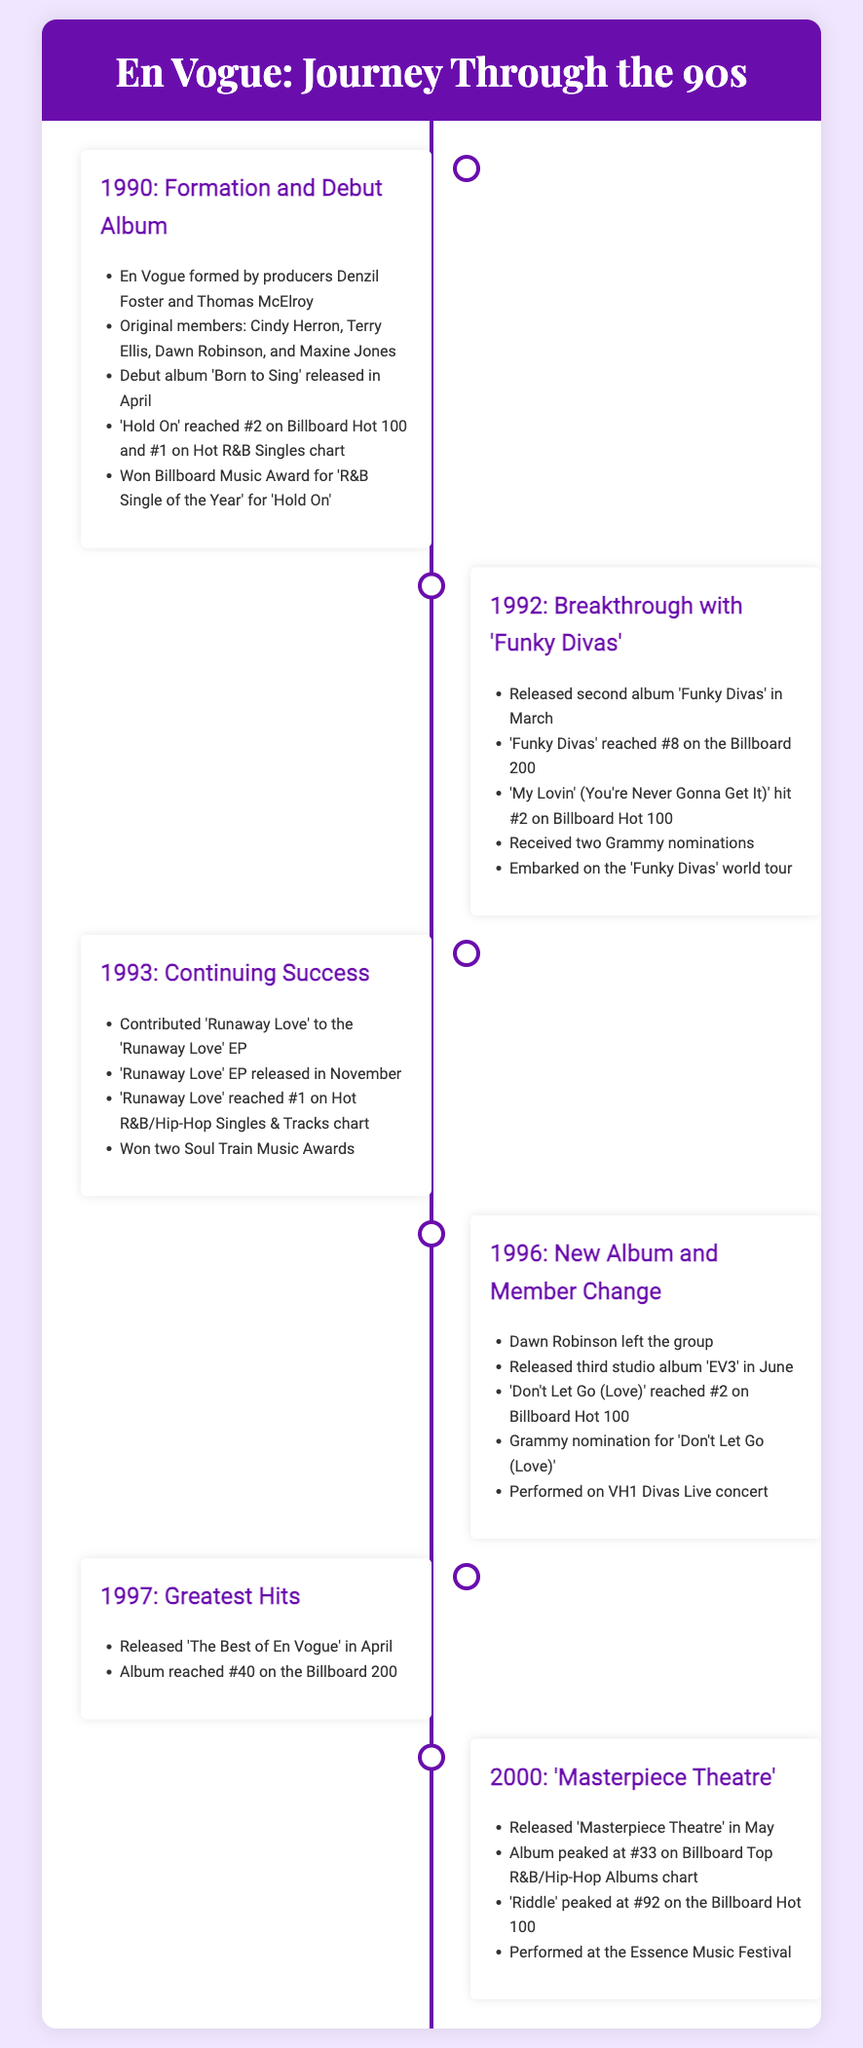What year was En Vogue formed? The document states that En Vogue was formed in 1990.
Answer: 1990 What was the title of En Vogue's debut album? The fact sheet mentions that their debut album is 'Born to Sing'.
Answer: Born to Sing Which single reached #1 on the Hot R&B Singles chart in 1990? According to the document, 'Hold On' reached #1 on the Hot R&B Singles chart.
Answer: Hold On How many Grammy nominations did En Vogue receive in 1992? The document states that they received two Grammy nominations in 1992.
Answer: Two What was the peak position of 'My Lovin' (You're Never Gonna Get It)' on the Billboard Hot 100? The timeline indicates that it hit #2 on the Billboard Hot 100.
Answer: #2 What significant event occurred in 1996? According to the document, Dawn Robinson left the group in 1996.
Answer: Dawn Robinson left What was the title of En Vogue's album released in 2000? The fact sheet notes that the album released in 2000 is 'Masterpiece Theatre'.
Answer: Masterpiece Theatre How many singles were mentioned from the album 'EV3'? The document refers to one single, 'Don't Let Go (Love)'.
Answer: One Which festival did En Vogue perform at in 2000? According to the fact sheet, they performed at the Essence Music Festival in 2000.
Answer: Essence Music Festival 